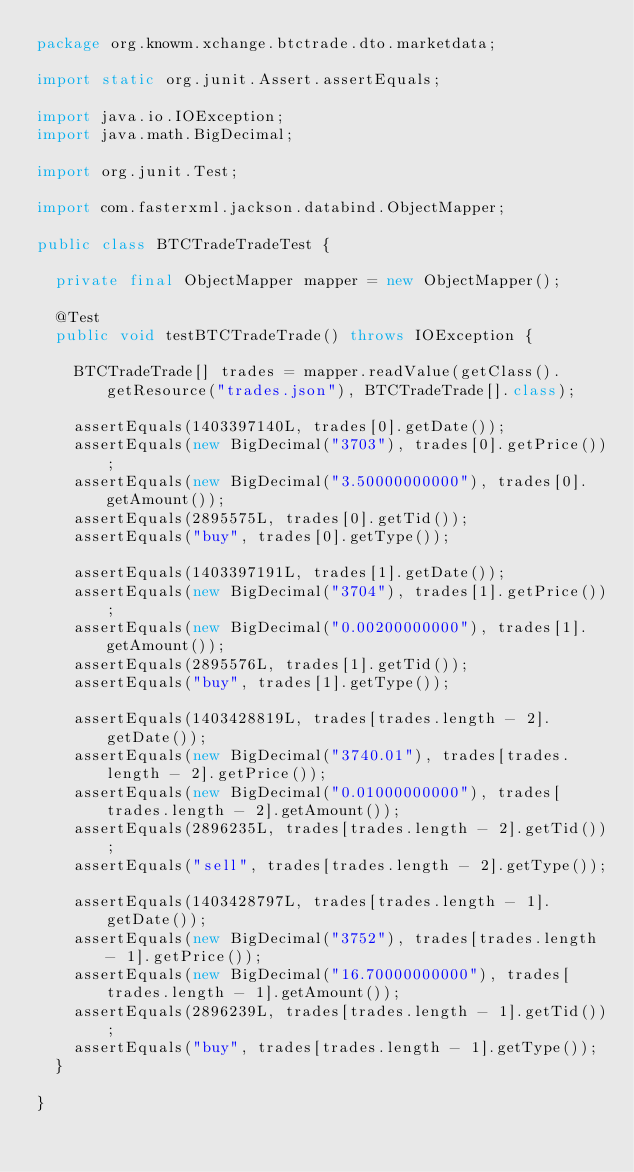Convert code to text. <code><loc_0><loc_0><loc_500><loc_500><_Java_>package org.knowm.xchange.btctrade.dto.marketdata;

import static org.junit.Assert.assertEquals;

import java.io.IOException;
import java.math.BigDecimal;

import org.junit.Test;

import com.fasterxml.jackson.databind.ObjectMapper;

public class BTCTradeTradeTest {

  private final ObjectMapper mapper = new ObjectMapper();

  @Test
  public void testBTCTradeTrade() throws IOException {

    BTCTradeTrade[] trades = mapper.readValue(getClass().getResource("trades.json"), BTCTradeTrade[].class);

    assertEquals(1403397140L, trades[0].getDate());
    assertEquals(new BigDecimal("3703"), trades[0].getPrice());
    assertEquals(new BigDecimal("3.50000000000"), trades[0].getAmount());
    assertEquals(2895575L, trades[0].getTid());
    assertEquals("buy", trades[0].getType());

    assertEquals(1403397191L, trades[1].getDate());
    assertEquals(new BigDecimal("3704"), trades[1].getPrice());
    assertEquals(new BigDecimal("0.00200000000"), trades[1].getAmount());
    assertEquals(2895576L, trades[1].getTid());
    assertEquals("buy", trades[1].getType());

    assertEquals(1403428819L, trades[trades.length - 2].getDate());
    assertEquals(new BigDecimal("3740.01"), trades[trades.length - 2].getPrice());
    assertEquals(new BigDecimal("0.01000000000"), trades[trades.length - 2].getAmount());
    assertEquals(2896235L, trades[trades.length - 2].getTid());
    assertEquals("sell", trades[trades.length - 2].getType());

    assertEquals(1403428797L, trades[trades.length - 1].getDate());
    assertEquals(new BigDecimal("3752"), trades[trades.length - 1].getPrice());
    assertEquals(new BigDecimal("16.70000000000"), trades[trades.length - 1].getAmount());
    assertEquals(2896239L, trades[trades.length - 1].getTid());
    assertEquals("buy", trades[trades.length - 1].getType());
  }

}
</code> 